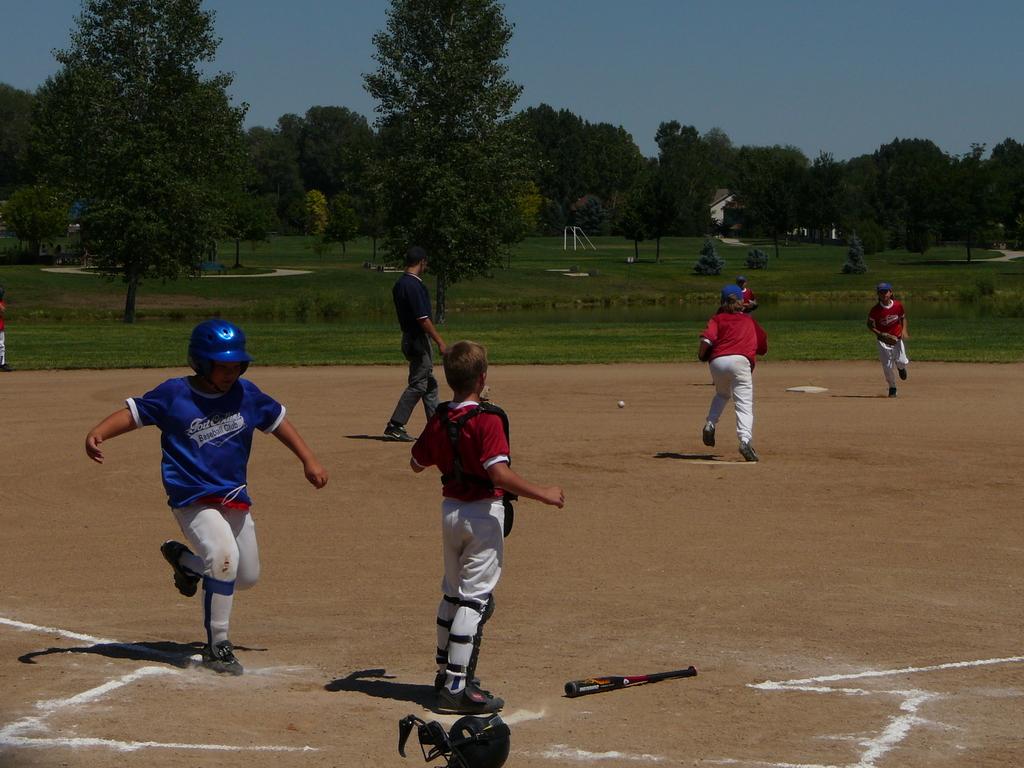What kind of club does it say on shirt?
Offer a terse response. Baseball. 